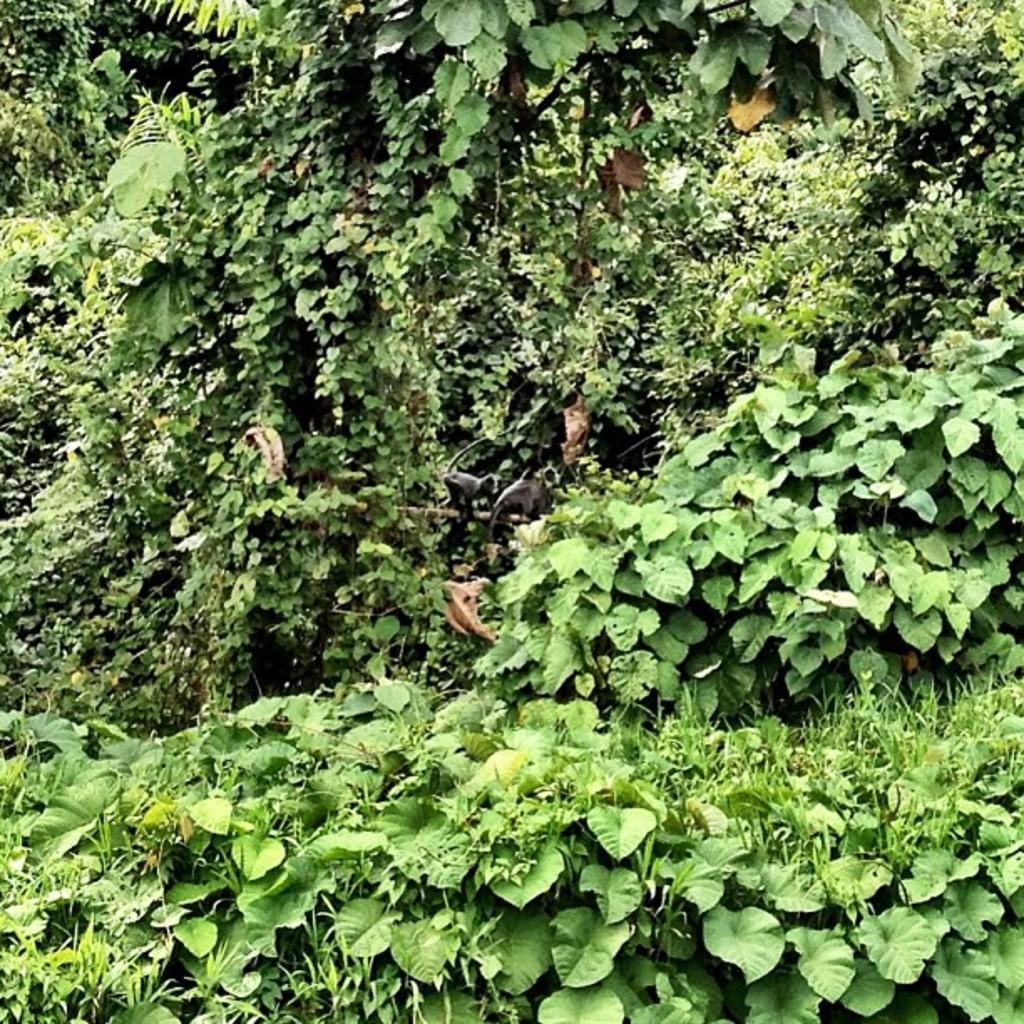Can you describe this image briefly? In this image we can see plants and trees. 